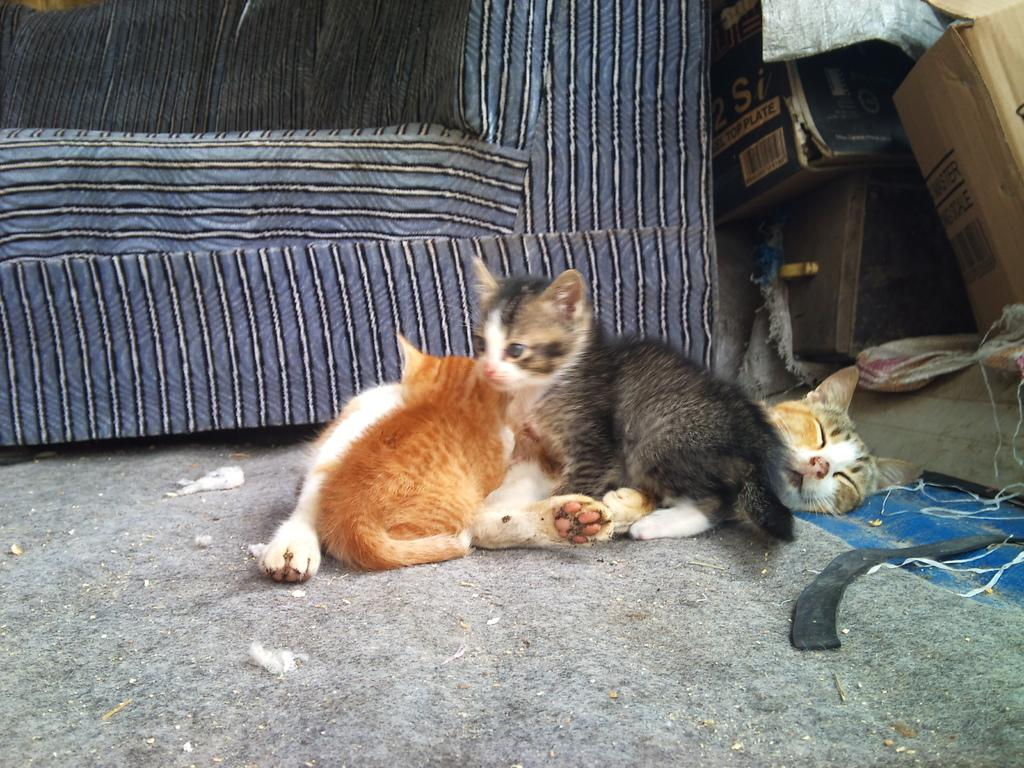What animals are lying on the floor in the image? There are cats lying on the floor in the image. What objects are present in the image besides the cats? There are cardboard boxes in the image. What type of furniture can be seen in the image? There is a sofa in the image. How many cents are visible on the floor in the image? There are no cents visible on the floor in the image. What type of afterthought is present in the image? There is no afterthought present in the image. 